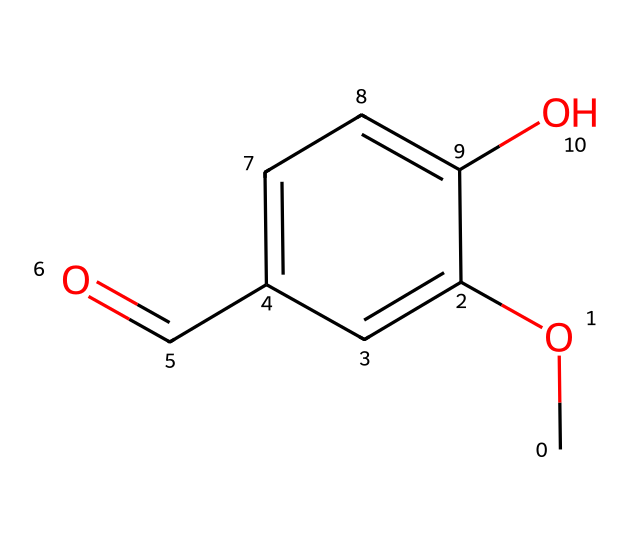What is the name of this chemical? The SMILES representation indicates it has a methoxy group (CO) attached to a phenolic compound with an aldehyde (C=O) and another hydroxyl group (O). This aligns with the structure of vanillin, which is well known for its presence in vanilla flavoring.
Answer: vanillin How many hydroxyl groups are present in the molecule? The chemical structure includes a hydroxyl group (O) attached directly to the aromatic ring. Although there is also a methoxy group, it is not a hydroxyl group; therefore, there is only one hydroxyl group present.
Answer: one How many carbon atoms are in the molecule? The molecular structure has a total of eight carbon atoms: one from the methoxy group, five from the aromatic ring, and two in the aldehyde group.
Answer: eight What functional group characterizes this as an ether? The presence of the methoxy group (−O−CH3) is what characterizes this molecule as an ether. Ethers are typically defined by the presence of an oxygen atom bonded to two alkyl or aryl groups.
Answer: methoxy group What type of aroma does vanillin evoke, and why is that significant in literature? Vanillin emits a sweet aroma due to the presence of the aromatic aldehyde group. This sweetness can symbolize comfort and nostalgia, resonating with O. Henry's themes of love, longing, and the simple pleasures of life depicted in confectioneries.
Answer: sweet aroma What is the primary functional group in this chemical structure? The most prominent functional group in vanillin's structure is the aldehyde group, characterized by the presence of the carbonyl (C=O) bonded to a hydrogen atom. This group contributes significantly to the molecule's flavor profile.
Answer: aldehyde group 